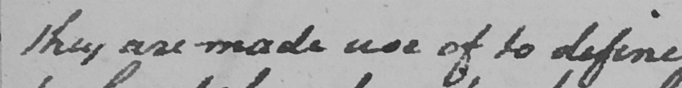What text is written in this handwritten line? they are made use of to define 